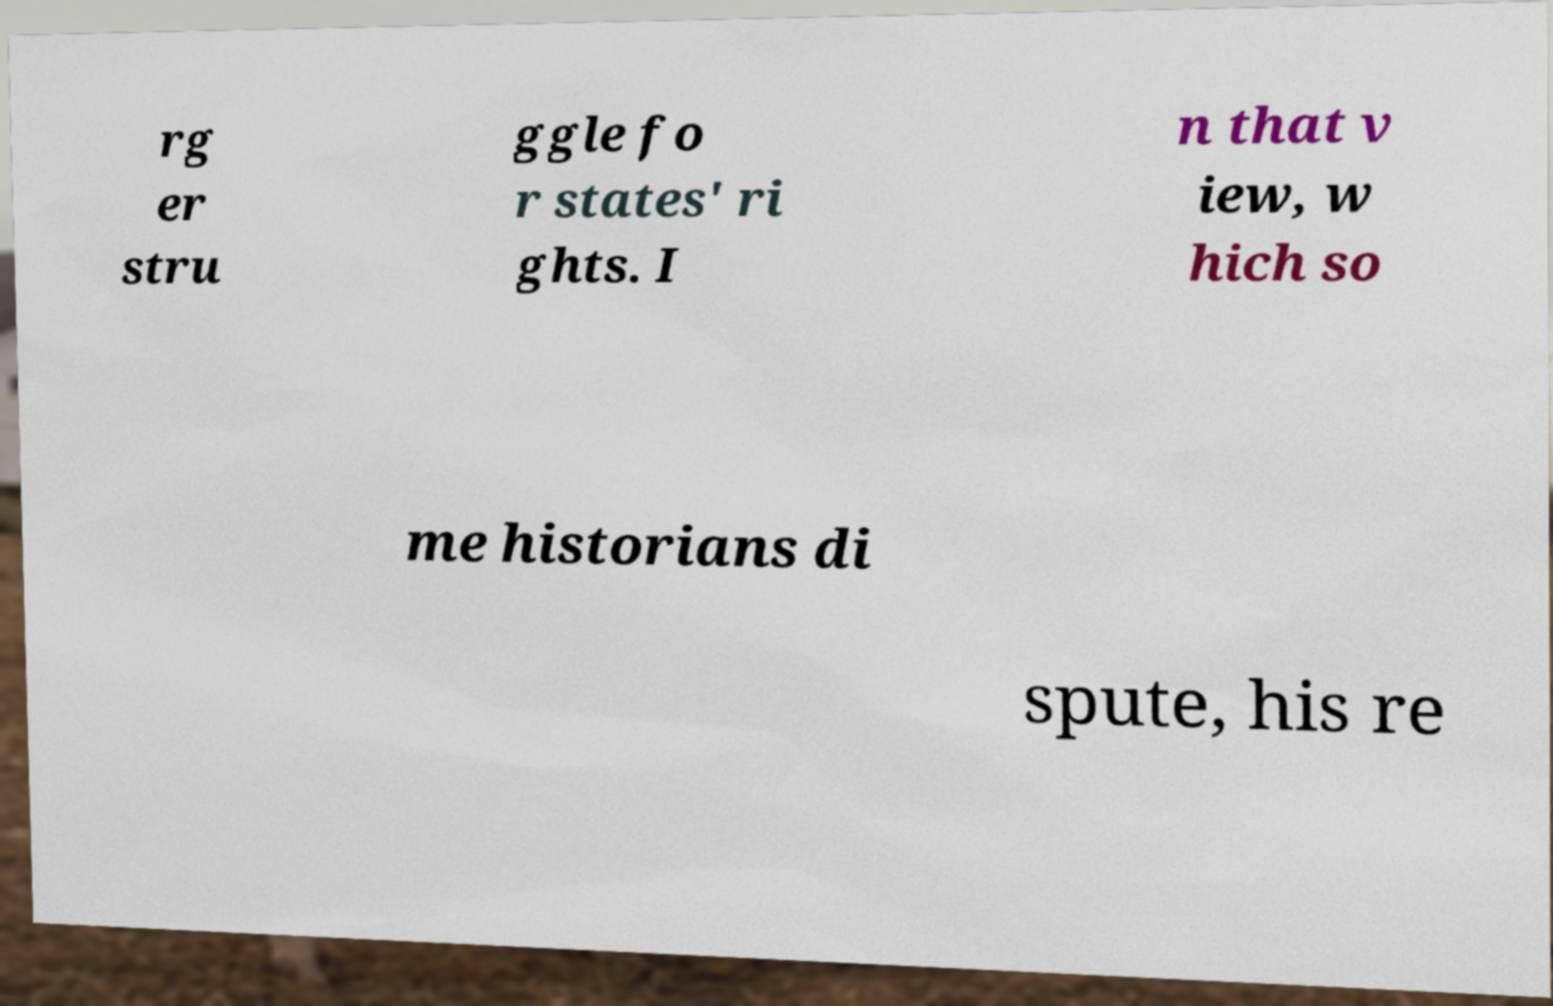For documentation purposes, I need the text within this image transcribed. Could you provide that? rg er stru ggle fo r states' ri ghts. I n that v iew, w hich so me historians di spute, his re 